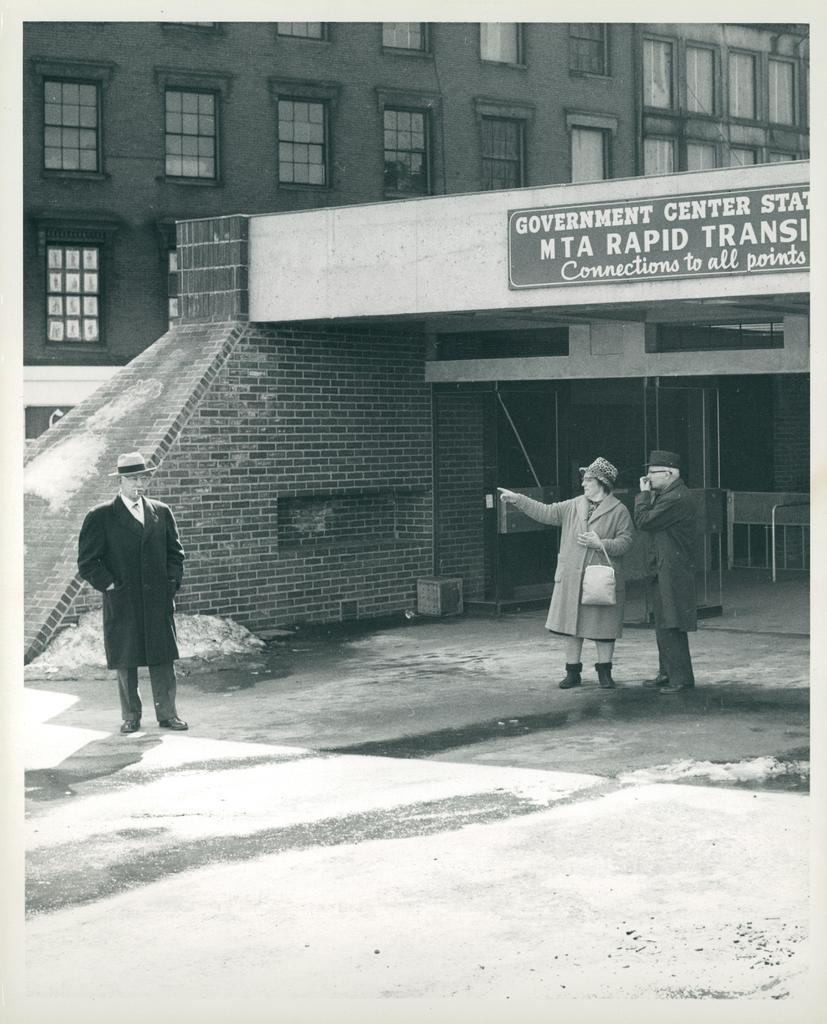Where are the people located in the image? There are people on both the right and left sides of the image. What can be seen in the background of the image? There is a building in the background of the image. What month is the governor celebrating in the image? There is no governor or celebration present in the image. 